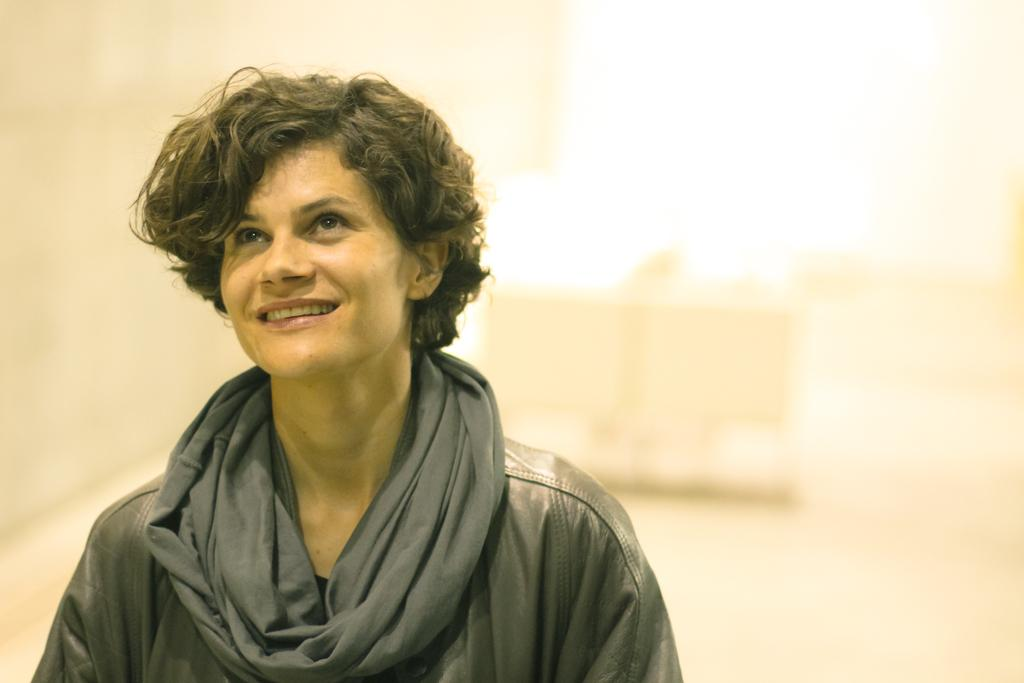What is located on the left side of the image? There is a person on the left side of the image. What color is the background of the image? The background of the image is white in color. What type of soup is being served in the image? There is no soup present in the image. How does the person rock back and forth in the image? There is no indication of the person's movements in the image. 